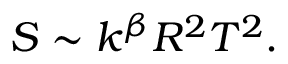<formula> <loc_0><loc_0><loc_500><loc_500>S \sim k ^ { \beta } R ^ { 2 } T ^ { 2 } .</formula> 